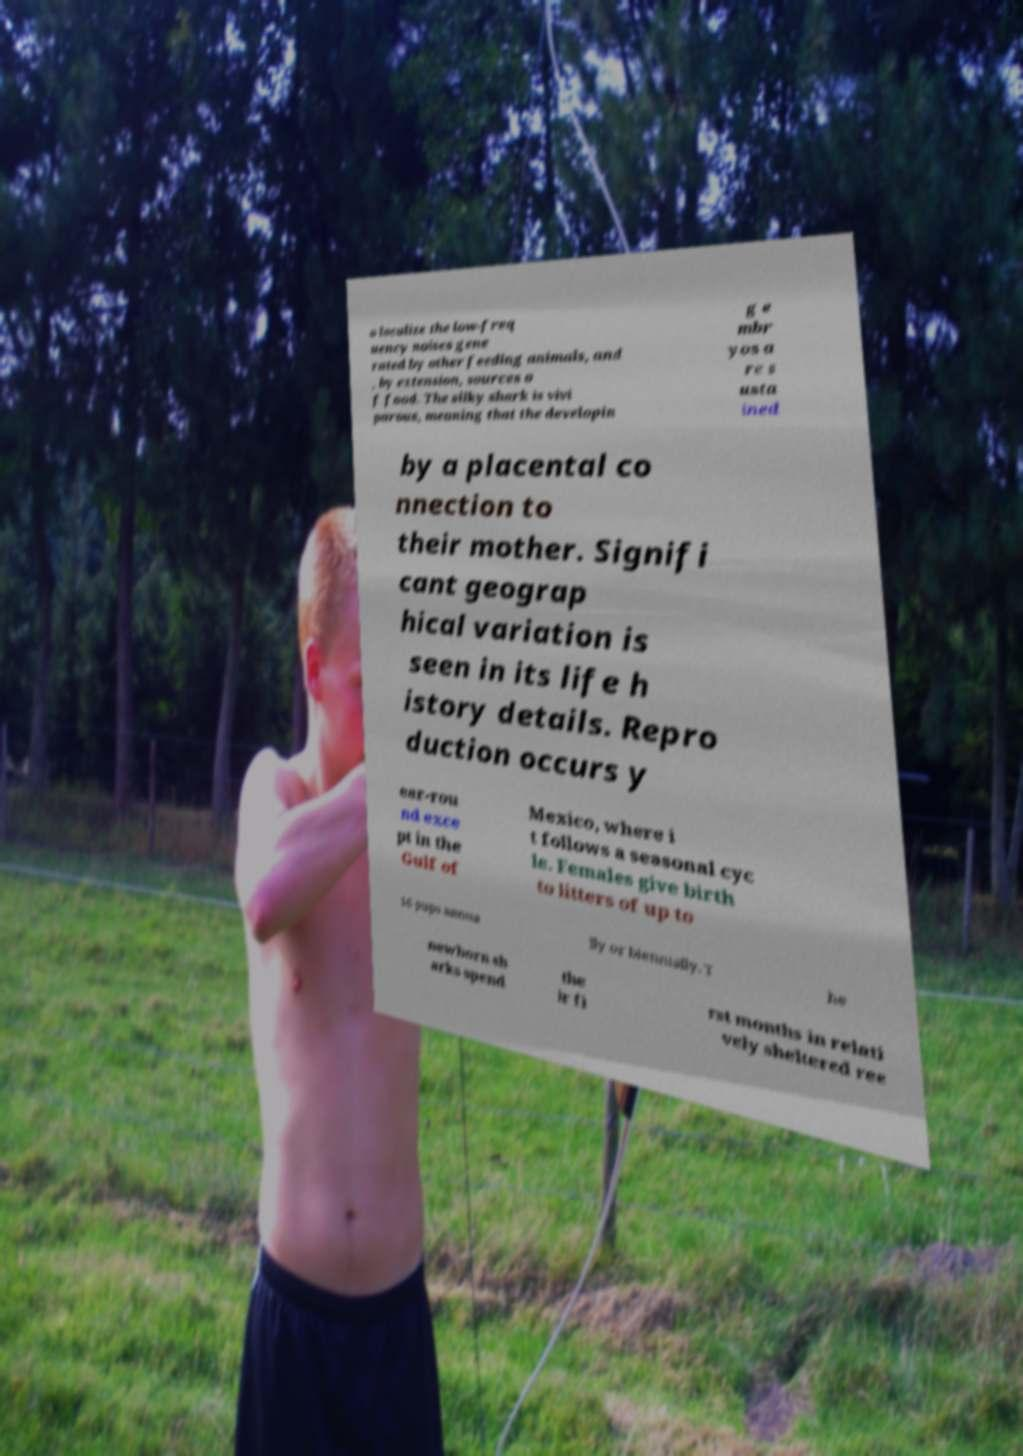Could you extract and type out the text from this image? o localize the low-freq uency noises gene rated by other feeding animals, and , by extension, sources o f food. The silky shark is vivi parous, meaning that the developin g e mbr yos a re s usta ined by a placental co nnection to their mother. Signifi cant geograp hical variation is seen in its life h istory details. Repro duction occurs y ear-rou nd exce pt in the Gulf of Mexico, where i t follows a seasonal cyc le. Females give birth to litters of up to 16 pups annua lly or biennially. T he newborn sh arks spend the ir fi rst months in relati vely sheltered ree 